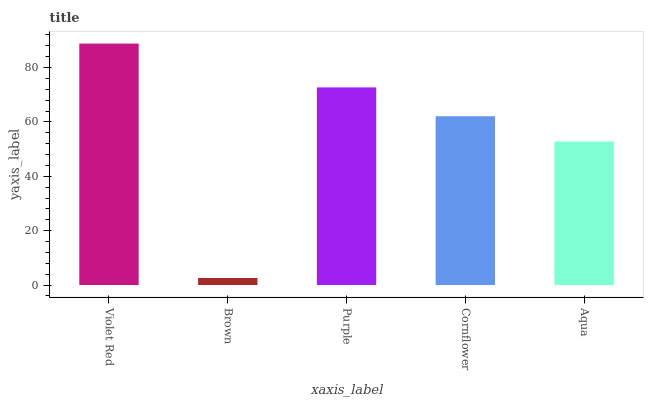Is Brown the minimum?
Answer yes or no. Yes. Is Violet Red the maximum?
Answer yes or no. Yes. Is Purple the minimum?
Answer yes or no. No. Is Purple the maximum?
Answer yes or no. No. Is Purple greater than Brown?
Answer yes or no. Yes. Is Brown less than Purple?
Answer yes or no. Yes. Is Brown greater than Purple?
Answer yes or no. No. Is Purple less than Brown?
Answer yes or no. No. Is Cornflower the high median?
Answer yes or no. Yes. Is Cornflower the low median?
Answer yes or no. Yes. Is Violet Red the high median?
Answer yes or no. No. Is Purple the low median?
Answer yes or no. No. 